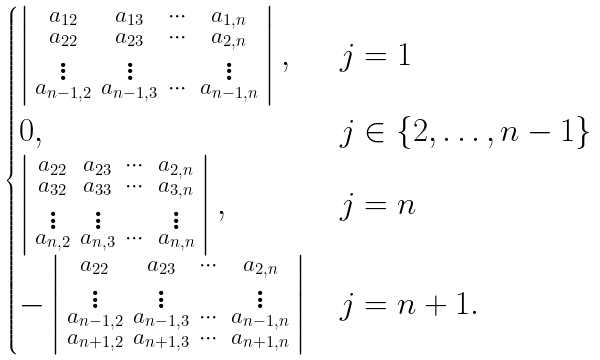<formula> <loc_0><loc_0><loc_500><loc_500>\begin{cases} \left | \begin{smallmatrix} a _ { 1 2 } & a _ { 1 3 } & \cdots & a _ { 1 , n } \\ a _ { 2 2 } & a _ { 2 3 } & \cdots & a _ { 2 , n } \\ \vdots & \vdots & & \vdots \\ a _ { n - 1 , 2 } & a _ { n - 1 , 3 } & \cdots & a _ { n - 1 , n } \end{smallmatrix} \right | , & j = 1 \\ 0 , & j \in \{ 2 , \dots , n - 1 \} \\ \left | \begin{smallmatrix} a _ { 2 2 } & a _ { 2 3 } & \cdots & a _ { 2 , n } \\ a _ { 3 2 } & a _ { 3 3 } & \cdots & a _ { 3 , n } \\ \vdots & \vdots & & \vdots \\ a _ { n , 2 } & a _ { n , 3 } & \cdots & a _ { n , n } \end{smallmatrix} \right | , & j = n \\ - \left | \begin{smallmatrix} a _ { 2 2 } & a _ { 2 3 } & \cdots & a _ { 2 , n } \\ \vdots & \vdots & & \vdots \\ a _ { n - 1 , 2 } & a _ { n - 1 , 3 } & \cdots & a _ { n - 1 , n } \\ a _ { n + 1 , 2 } & a _ { n + 1 , 3 } & \cdots & a _ { n + 1 , n } \\ \end{smallmatrix} \right | & j = n + 1 . \end{cases}</formula> 